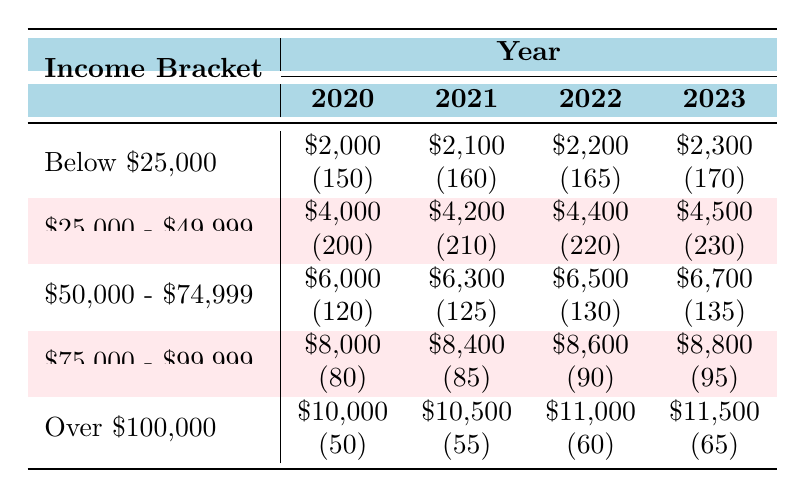What was the total amount paid in child support for the income bracket "Below $25,000" in 2022? For the income bracket "Below $25,000" in 2022, the amount paid is $2,200. This is found in the corresponding row and column for that year in the table.
Answer: $2,200 How many cases were there in the "$25,000 - $49,999" income bracket in 2021? The number of cases in the "$25,000 - $49,999" income bracket for 2021 is 210, as indicated in that row for the year 2021.
Answer: 210 What is the difference in the amount paid between "$50,000 - $74,999" in 2020 and 2023? The amount paid in 2020 for the "$50,000 - $74,999" bracket is $6,000, whereas in 2023 it is $6,700. The difference is $6,700 - $6,000 = $700.
Answer: $700 Is the number of cases in "Over $100,000" increasing each year? Yes, the number of cases in "Over $100,000" has increased from 50 in 2020 to 65 in 2023, showing a consistent increase each year.
Answer: Yes What was the average amount paid across all income brackets in 2022? To calculate the average amount paid in 2022, we sum the amounts: $2,200 + $4,400 + $6,500 + $8,600 + $11,000 = $32,700. There are 5 income brackets, so the average is $32,700 / 5 = $6,540.
Answer: $6,540 How many total cases were there in 2023 across all income brackets? To find the total number of cases in 2023, we sum the number of cases for each bracket: 170 (Below $25,000) + 230 ($25,000 - $49,999) + 135 ($50,000 - $74,999) + 95 ($75,000 - $99,999) + 65 (Over $100,000) = 695 cases.
Answer: 695 What is the growth trend in amounts paid from 2020 to 2023 for the "$75,000 - $99,999" income bracket? The amounts paid in this bracket are $8,000 in 2020 and $8,800 in 2023, indicating a growth of $800 over the three years, which shows an upward trend.
Answer: Upward trend In which income bracket does the highest number of cases occur in 2023? The highest number of cases in 2023 is in the "$25,000 - $49,999" bracket with 230 cases, which can be compared against the other brackets listed for that year.
Answer: "$25,000 - $49,999" What is the total amount paid for all income brackets in 2020? To find the total amount paid in 2020, add the amounts: $2,000 (Below $25,000) + $4,000 ($25,000 - $49,999) + $6,000 ($50,000 - $74,999) + $8,000 ($75,000 - $99,999) + $10,000 (Over $100,000) = $30,000.
Answer: $30,000 